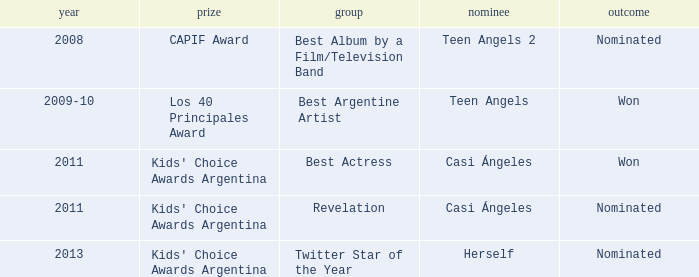In what category was Herself nominated? Twitter Star of the Year. 